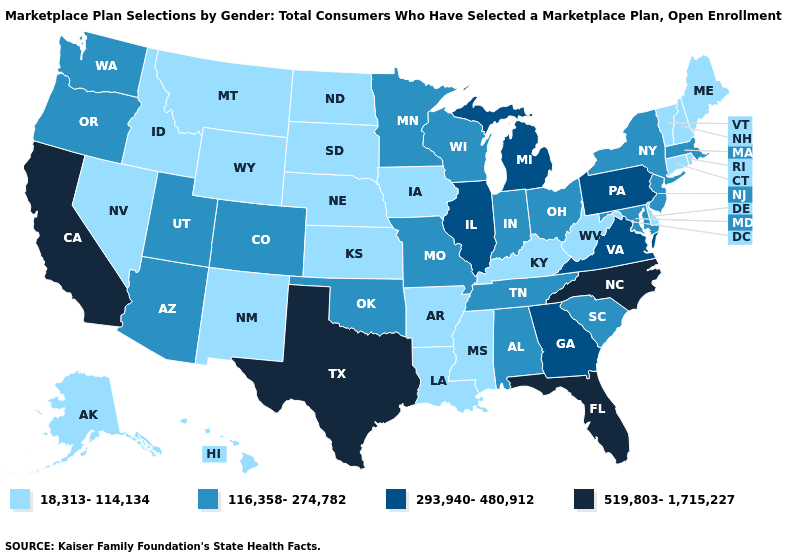What is the value of Montana?
Answer briefly. 18,313-114,134. Name the states that have a value in the range 116,358-274,782?
Short answer required. Alabama, Arizona, Colorado, Indiana, Maryland, Massachusetts, Minnesota, Missouri, New Jersey, New York, Ohio, Oklahoma, Oregon, South Carolina, Tennessee, Utah, Washington, Wisconsin. Does the first symbol in the legend represent the smallest category?
Answer briefly. Yes. Name the states that have a value in the range 293,940-480,912?
Give a very brief answer. Georgia, Illinois, Michigan, Pennsylvania, Virginia. What is the value of Tennessee?
Quick response, please. 116,358-274,782. Name the states that have a value in the range 18,313-114,134?
Give a very brief answer. Alaska, Arkansas, Connecticut, Delaware, Hawaii, Idaho, Iowa, Kansas, Kentucky, Louisiana, Maine, Mississippi, Montana, Nebraska, Nevada, New Hampshire, New Mexico, North Dakota, Rhode Island, South Dakota, Vermont, West Virginia, Wyoming. Does Nevada have the lowest value in the USA?
Answer briefly. Yes. Does Missouri have a higher value than Hawaii?
Short answer required. Yes. What is the value of Michigan?
Keep it brief. 293,940-480,912. Name the states that have a value in the range 519,803-1,715,227?
Be succinct. California, Florida, North Carolina, Texas. Which states have the lowest value in the USA?
Be succinct. Alaska, Arkansas, Connecticut, Delaware, Hawaii, Idaho, Iowa, Kansas, Kentucky, Louisiana, Maine, Mississippi, Montana, Nebraska, Nevada, New Hampshire, New Mexico, North Dakota, Rhode Island, South Dakota, Vermont, West Virginia, Wyoming. What is the lowest value in the South?
Give a very brief answer. 18,313-114,134. Among the states that border Maryland , does Virginia have the highest value?
Write a very short answer. Yes. Name the states that have a value in the range 18,313-114,134?
Be succinct. Alaska, Arkansas, Connecticut, Delaware, Hawaii, Idaho, Iowa, Kansas, Kentucky, Louisiana, Maine, Mississippi, Montana, Nebraska, Nevada, New Hampshire, New Mexico, North Dakota, Rhode Island, South Dakota, Vermont, West Virginia, Wyoming. How many symbols are there in the legend?
Write a very short answer. 4. 